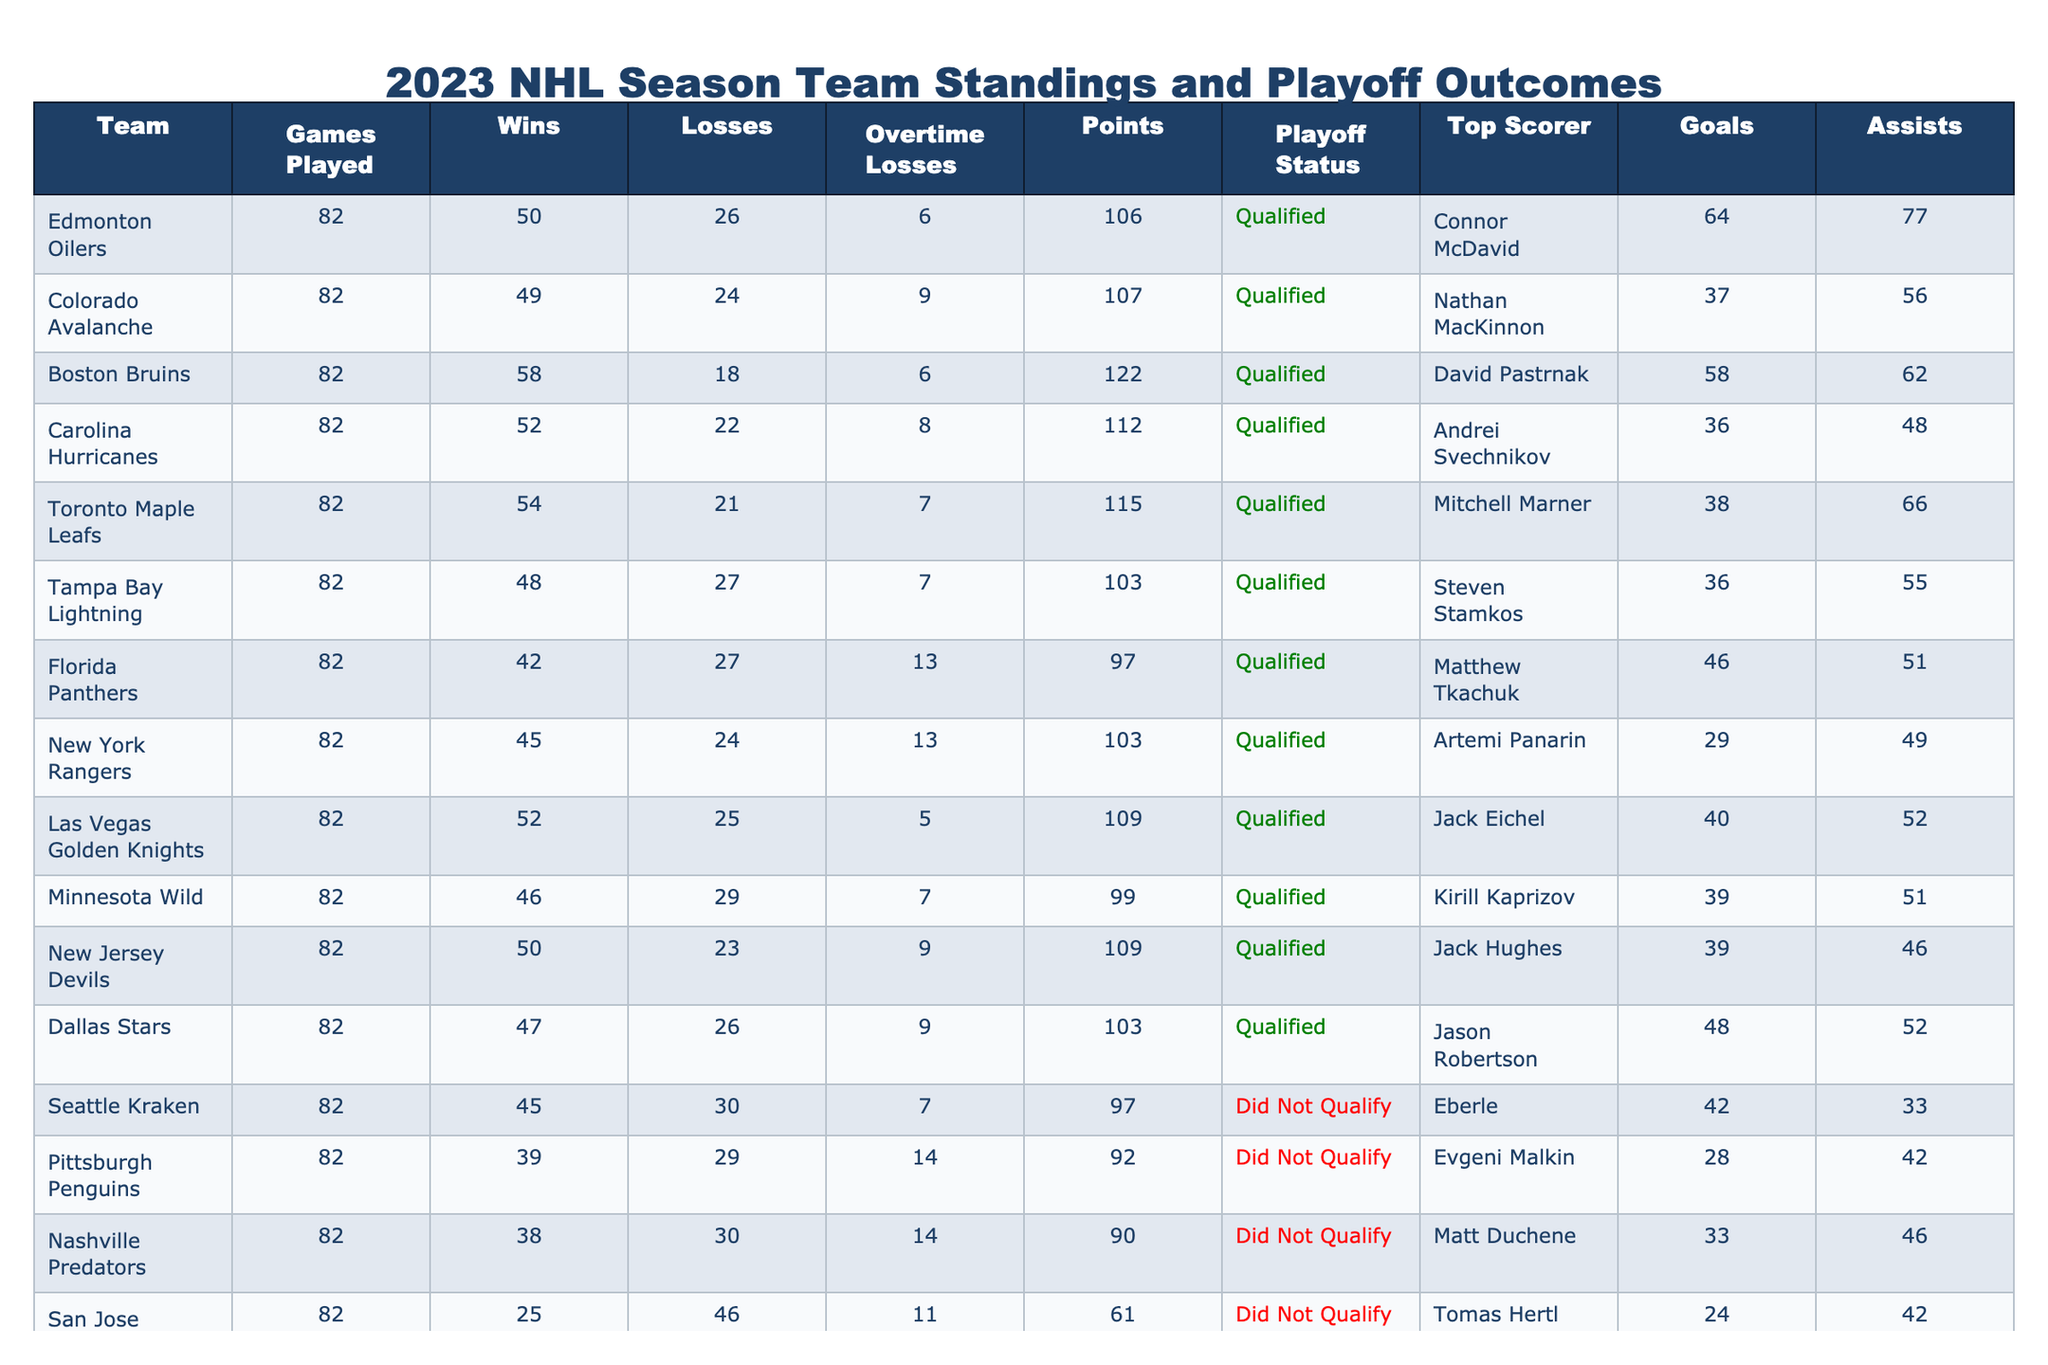What team had the most points in the 2023 NHL season? The team with the highest points in the standings is the Boston Bruins, with a total of 122 points.
Answer: Boston Bruins How many teams qualified for the playoffs in the 2023 NHL season? There are 16 teams in the playoffs; the table indicates that 8 teams have a playoff status of "Qualified."
Answer: 8 Who was the top scorer for the Edmonton Oilers in the 2023 NHL season? The top scorer for the Edmonton Oilers is Connor McDavid, who scored 64 goals.
Answer: Connor McDavid Which team had the least amount of wins in the season? The San Jose Sharks had the fewest wins, with a total of 25.
Answer: San Jose Sharks How many total goals did the New Jersey Devils score compared to the Minnesota Wild? The New Jersey Devils scored 39 goals, and the Minnesota Wild scored 39 goals, so they are tied with 39 goals each.
Answer: Tied at 39 goals What was the average points of the teams that did not qualify for the playoffs? The teams that did not qualify had points of 97, 92, 90, 61, 72, 87, and 48. The total is 90 + 92 + 97 + 48 + 61 + 72 = 460, divided by 7 teams gives an average of about 65.71.
Answer: 65.71 Is it true that the Florida Panthers scored more goals than the Pittsburgh Penguins? The Florida Panthers scored 46 goals, while the Pittsburgh Penguins scored 28 goals. Therefore, it is true that the Panthers scored more goals.
Answer: Yes What is the difference in points between the Dallas Stars and the Florida Panthers? The Dallas Stars finished with 103 points and the Florida Panthers had 97 points. The difference is 103 - 97 = 6 points.
Answer: 6 points Which qualified team had the lowest number of assists by their top scorer? The qualified team with the lowest assists from their top scorer is the Dallas Stars, with 52 assists.
Answer: Dallas Stars If you combine the goals of top scorers from the Toronto Maple Leafs and Carolina Hurricanes, how many total goals do they have? The Toronto Maple Leafs' top scorer, Mitchell Marner, scored 38 goals, and the Carolina Hurricanes' top scorer, Andrei Svechnikov, scored 36 goals. The total is 38 + 36 = 74 goals.
Answer: 74 goals What percentage of qualified teams scored more than 50 goals from their top scorers? There are 8 qualified teams. The top scorers of the Boston Bruins, Edmonton Oilers, Carolina Hurricanes, Toronto Maple Leafs, Tampa Bay Lightning, New Jersey Devils, and Las Vegas Golden Knights scored more than 50 goals (7 out of 8). The percentage is (7/8)*100 = 87.5%.
Answer: 87.5% 